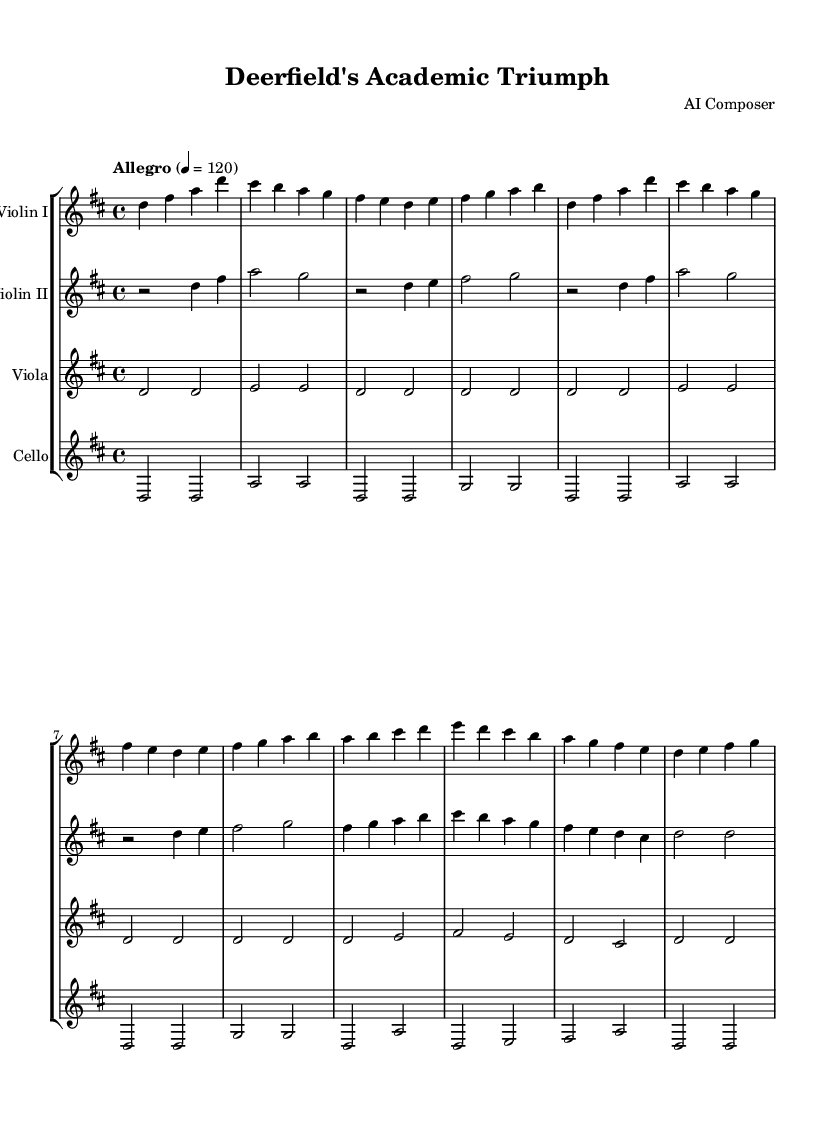What is the key signature of this music? The key signature indicated in the music is D major, which has two sharps (F# and C#). This can be confirmed by looking at the beginning of the staves where the key signature is typically placed.
Answer: D major What is the time signature of this piece? The time signature is 4/4, which means there are four beats in each measure with each beat being a quarter note. This information is found at the beginning of the score, directly after the key signature.
Answer: 4/4 What is the tempo marking for the symphony? The tempo marking is "Allegro," indicating a fast and lively pace. The numerical indication "4 = 120" specifies that there are 120 beats per minute, which is typical of an Allegro tempo. This information is presented at the start of the score.
Answer: Allegro How many distinct themes are present in the piece? There are two distinct themes indicated in the music: Theme A and Theme B. The score specifies these themes through labeling and differentiation in their musical content, as evidenced by the repetition of phrases unique to each theme.
Answer: Two Which instrument has the highest pitch in the score? The Violin I part typically plays in a higher pitch range than the other string instruments in this composition. This can be deduced by comparing the ranges of all instruments in the score.
Answer: Violin I What is the rhythmic value of the first note in the cello part? The first note in the cello part is a whole note, which means it lasts for four beats, represented by the note being drawn as an open note head with no stem in the score.
Answer: Whole note What is the dynamic marking for the cello part? The dynamic marking for the cello part appears to be "p," which indicates that the section should be played softly. This is typically found at the beginning of the staff for the cello.
Answer: p 